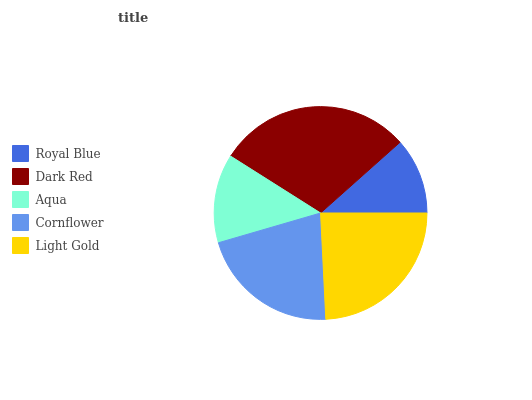Is Royal Blue the minimum?
Answer yes or no. Yes. Is Dark Red the maximum?
Answer yes or no. Yes. Is Aqua the minimum?
Answer yes or no. No. Is Aqua the maximum?
Answer yes or no. No. Is Dark Red greater than Aqua?
Answer yes or no. Yes. Is Aqua less than Dark Red?
Answer yes or no. Yes. Is Aqua greater than Dark Red?
Answer yes or no. No. Is Dark Red less than Aqua?
Answer yes or no. No. Is Cornflower the high median?
Answer yes or no. Yes. Is Cornflower the low median?
Answer yes or no. Yes. Is Royal Blue the high median?
Answer yes or no. No. Is Aqua the low median?
Answer yes or no. No. 